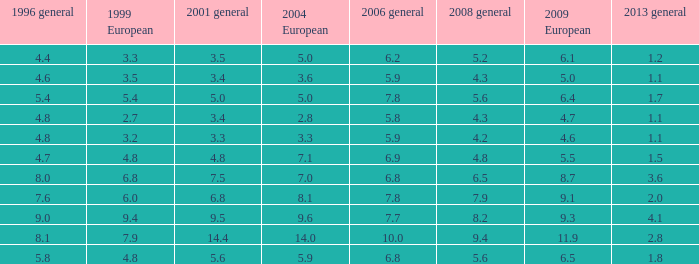Give me the full table as a dictionary. {'header': ['1996 general', '1999 European', '2001 general', '2004 European', '2006 general', '2008 general', '2009 European', '2013 general'], 'rows': [['4.4', '3.3', '3.5', '5.0', '6.2', '5.2', '6.1', '1.2'], ['4.6', '3.5', '3.4', '3.6', '5.9', '4.3', '5.0', '1.1'], ['5.4', '5.4', '5.0', '5.0', '7.8', '5.6', '6.4', '1.7'], ['4.8', '2.7', '3.4', '2.8', '5.8', '4.3', '4.7', '1.1'], ['4.8', '3.2', '3.3', '3.3', '5.9', '4.2', '4.6', '1.1'], ['4.7', '4.8', '4.8', '7.1', '6.9', '4.8', '5.5', '1.5'], ['8.0', '6.8', '7.5', '7.0', '6.8', '6.5', '8.7', '3.6'], ['7.6', '6.0', '6.8', '8.1', '7.8', '7.9', '9.1', '2.0'], ['9.0', '9.4', '9.5', '9.6', '7.7', '8.2', '9.3', '4.1'], ['8.1', '7.9', '14.4', '14.0', '10.0', '9.4', '11.9', '2.8'], ['5.8', '4.8', '5.6', '5.9', '6.8', '5.6', '6.5', '1.8']]} What is the maximum value for general 2008 when there is below None. 